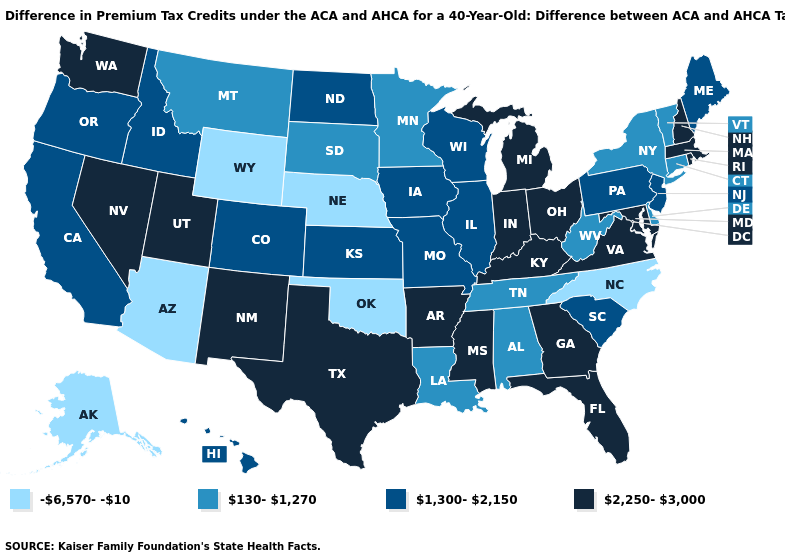Name the states that have a value in the range 1,300-2,150?
Short answer required. California, Colorado, Hawaii, Idaho, Illinois, Iowa, Kansas, Maine, Missouri, New Jersey, North Dakota, Oregon, Pennsylvania, South Carolina, Wisconsin. What is the value of Arizona?
Concise answer only. -6,570--10. Does Massachusetts have a higher value than Maryland?
Quick response, please. No. What is the value of New York?
Keep it brief. 130-1,270. What is the value of New Hampshire?
Be succinct. 2,250-3,000. What is the value of Washington?
Give a very brief answer. 2,250-3,000. What is the value of Tennessee?
Short answer required. 130-1,270. Does Colorado have the same value as South Carolina?
Write a very short answer. Yes. Name the states that have a value in the range 2,250-3,000?
Write a very short answer. Arkansas, Florida, Georgia, Indiana, Kentucky, Maryland, Massachusetts, Michigan, Mississippi, Nevada, New Hampshire, New Mexico, Ohio, Rhode Island, Texas, Utah, Virginia, Washington. What is the value of South Dakota?
Concise answer only. 130-1,270. What is the highest value in states that border Michigan?
Concise answer only. 2,250-3,000. What is the value of Michigan?
Quick response, please. 2,250-3,000. What is the value of Kentucky?
Short answer required. 2,250-3,000. Name the states that have a value in the range 1,300-2,150?
Answer briefly. California, Colorado, Hawaii, Idaho, Illinois, Iowa, Kansas, Maine, Missouri, New Jersey, North Dakota, Oregon, Pennsylvania, South Carolina, Wisconsin. 